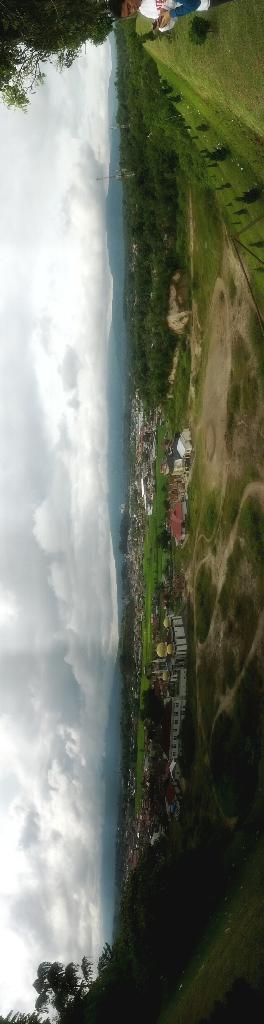Could you give a brief overview of what you see in this image? This is the picture of a place where we have some fields in which there are some trees, plants, grass, houses and a person to the side. 